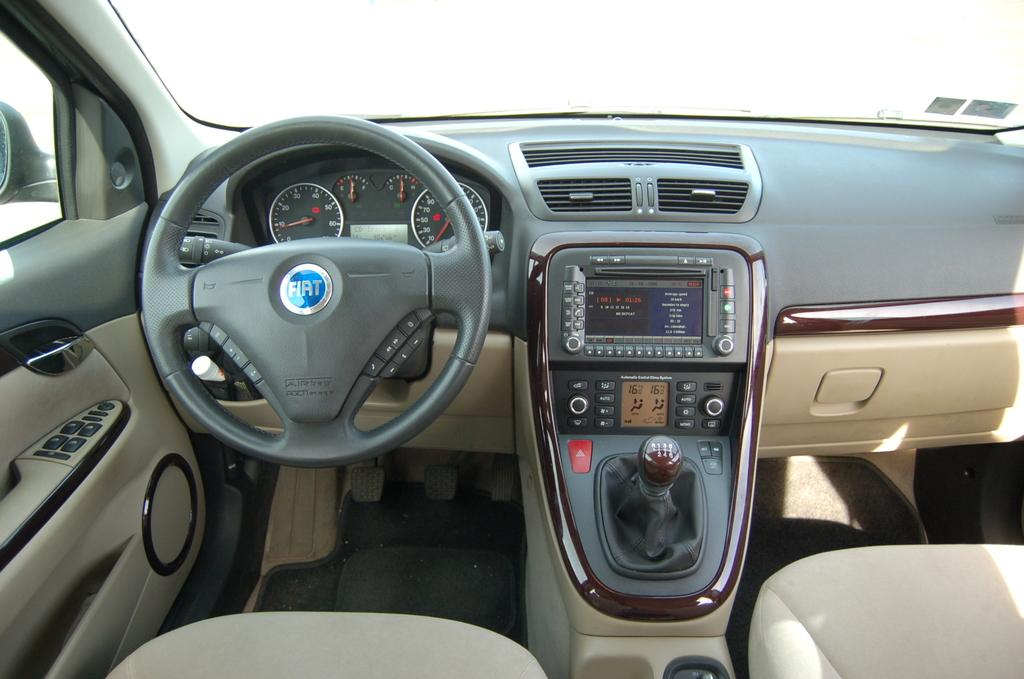What type of environment is depicted in the image? The image shows an inside view of a vehicle. What is the primary control mechanism in the vehicle? There is a steering wheel in the image. How can the driver monitor their speed in the vehicle? A speedometer is visible in the image. What device is present for displaying information or entertainment? There is a screen in the image. How can the driver change the vehicle's speed and direction? The gear rod is present in the image. What are the seats used for in the vehicle? There are seats in the image for passengers to sit on. What additional items can be seen inside the vehicle? There are some objects in the vehicle. How many parents are present in the vehicle in the image? There is no information about parents in the image; it shows an inside view of a vehicle with various components and features. 